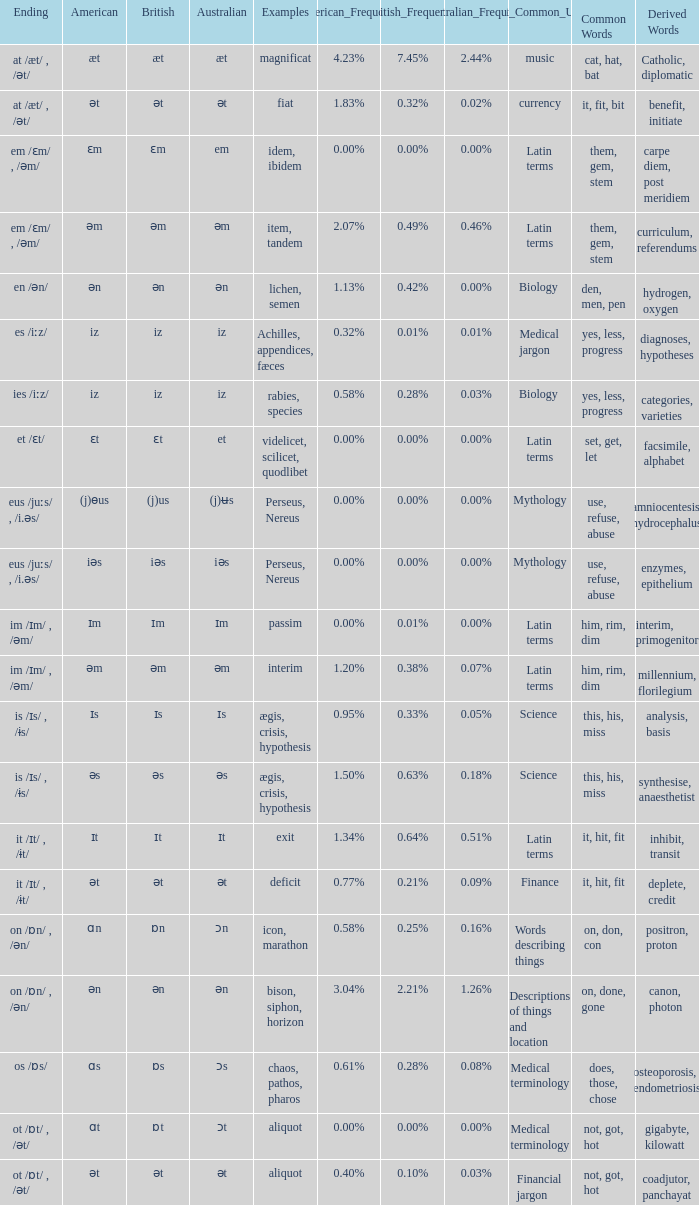Which American has British of ɛm? Ɛm. Parse the table in full. {'header': ['Ending', 'American', 'British', 'Australian', 'Examples', 'American_Frequency', 'British_Frequency', 'Australian_Frequency', 'Most_Common_Usage', 'Common Words', 'Derived Words'], 'rows': [['at /æt/ , /ət/', 'æt', 'æt', 'æt', 'magnificat', '4.23%', '7.45%', '2.44%', 'music', 'cat, hat, bat ', 'Catholic, diplomatic '], ['at /æt/ , /ət/', 'ət', 'ət', 'ət', 'fiat', '1.83%', '0.32%', '0.02%', 'currency', 'it, fit, bit ', 'benefit, initiate'], ['em /ɛm/ , /əm/', 'ɛm', 'ɛm', 'em', 'idem, ibidem', '0.00%', '0.00%', '0.00%', 'Latin terms', 'them, gem, stem', 'carpe diem, post meridiem '], ['em /ɛm/ , /əm/', 'əm', 'əm', 'əm', 'item, tandem', '2.07%', '0.49%', '0.46%', 'Latin terms', 'them, gem, stem', 'curriculum, referendums'], ['en /ən/', 'ən', 'ən', 'ən', 'lichen, semen', '1.13%', '0.42%', '0.00%', 'Biology ', 'den, men, pen', 'hydrogen, oxygen'], ['es /iːz/', 'iz', 'iz', 'iz', 'Achilles, appendices, fæces', '0.32%', '0.01%', '0.01%', 'Medical jargon ', 'yes, less, progress', 'diagnoses, hypotheses'], ['ies /iːz/', 'iz', 'iz', 'iz', 'rabies, species', '0.58%', '0.28%', '0.03%', 'Biology ', 'yes, less, progress', 'categories, varieties'], ['et /ɛt/', 'ɛt', 'ɛt', 'et', 'videlicet, scilicet, quodlibet', '0.00%', '0.00%', '0.00%', 'Latin terms', 'set, get, let', 'facsimile, alphabet'], ['eus /juːs/ , /i.əs/', '(j)ɵus', '(j)us', '(j)ʉs', 'Perseus, Nereus', '0.00%', '0.00%', '0.00%', 'Mythology', 'use, refuse, abuse', 'amniocentesis, hydrocephalus'], ['eus /juːs/ , /i.əs/', 'iəs', 'iəs', 'iəs', 'Perseus, Nereus', '0.00%', '0.00%', '0.00%', 'Mythology', 'use, refuse, abuse', 'enzymes, epithelium '], ['im /ɪm/ , /əm/', 'ɪm', 'ɪm', 'ɪm', 'passim', '0.00%', '0.01%', '0.00%', 'Latin terms', 'him, rim, dim', 'interim, primogenitor '], ['im /ɪm/ , /əm/', 'əm', 'əm', 'əm', 'interim', '1.20%', '0.38%', '0.07%', 'Latin terms', 'him, rim, dim', 'millennium, florilegium'], ['is /ɪs/ , /ɨs/', 'ɪs', 'ɪs', 'ɪs', 'ægis, crisis, hypothesis', '0.95%', '0.33%', '0.05%', 'Science ', 'this, his, miss', 'analysis, basis '], ['is /ɪs/ , /ɨs/', 'əs', 'əs', 'əs', 'ægis, crisis, hypothesis', '1.50%', '0.63%', '0.18%', 'Science ', 'this, his, miss', 'synthesise, anaesthetist '], ['it /ɪt/ , /ɨt/', 'ɪt', 'ɪt', 'ɪt', 'exit', '1.34%', '0.64%', '0.51%', 'Latin terms', 'it, hit, fit', 'inhibit, transit '], ['it /ɪt/ , /ɨt/', 'ət', 'ət', 'ət', 'deficit', '0.77%', '0.21%', '0.09%', 'Finance', 'it, hit, fit', 'deplete, credit '], ['on /ɒn/ , /ən/', 'ɑn', 'ɒn', 'ɔn', 'icon, marathon', '0.58%', '0.25%', '0.16%', 'Words describing things', 'on, don, con', 'positron, proton '], ['on /ɒn/ , /ən/', 'ən', 'ən', 'ən', 'bison, siphon, horizon', '3.04%', '2.21%', '1.26%', 'Descriptions of things and location', 'on, done, gone', 'canon, photon '], ['os /ɒs/', 'ɑs', 'ɒs', 'ɔs', 'chaos, pathos, pharos', '0.61%', '0.28%', '0.08%', 'Medical terminology', 'does, those, chose', 'osteoporosis, endometriosis'], ['ot /ɒt/ , /ət/', 'ɑt', 'ɒt', 'ɔt', 'aliquot', '0.00%', '0.00%', '0.00%', 'Medical terminology ', 'not, got, hot', 'gigabyte, kilowatt'], ['ot /ɒt/ , /ət/', 'ət', 'ət', 'ət', 'aliquot', '0.40%', '0.10%', '0.03%', 'Financial jargon ', 'not, got, hot', 'coadjutor, panchayat']]} 